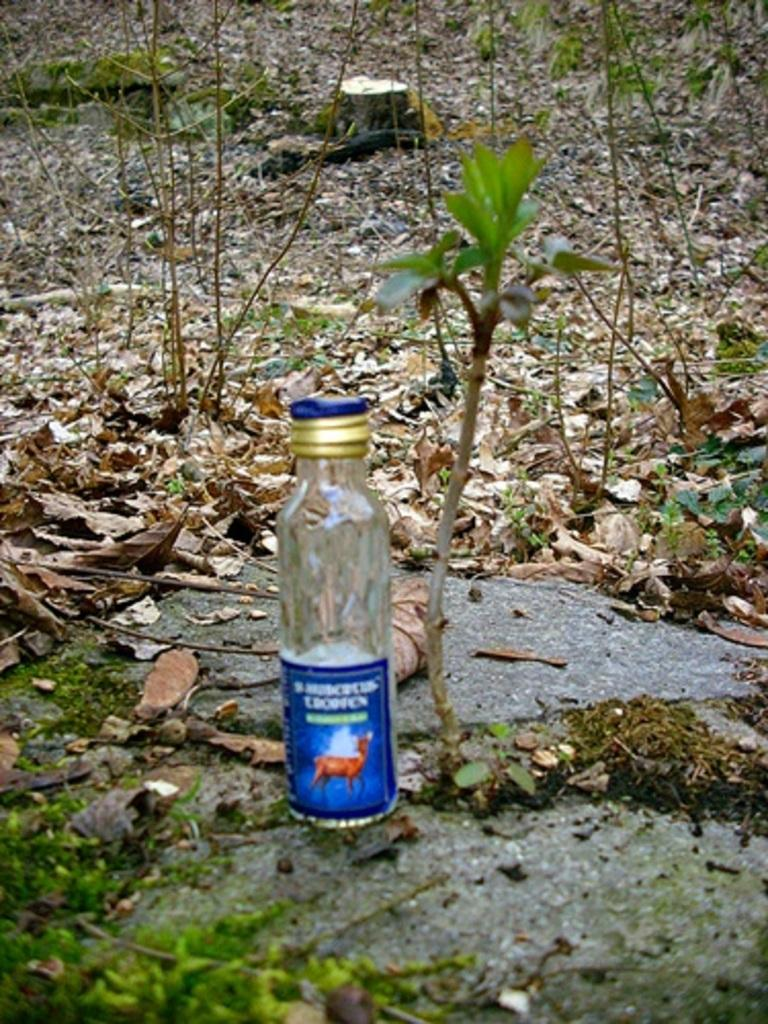What object is placed on a rock in the image? There is a bottle on a rock in the image. What can be seen in the background of the image? There are trees visible in the background of the image. What type of vegetation is present in the image? Leaves are present in the image. What type of prose is written on the bottle in the image? There is no prose written on the bottle in the image. What type of collar is visible on the leaves in the image? There are no collars present in the image, as it features a bottle on a rock and trees in the background. 